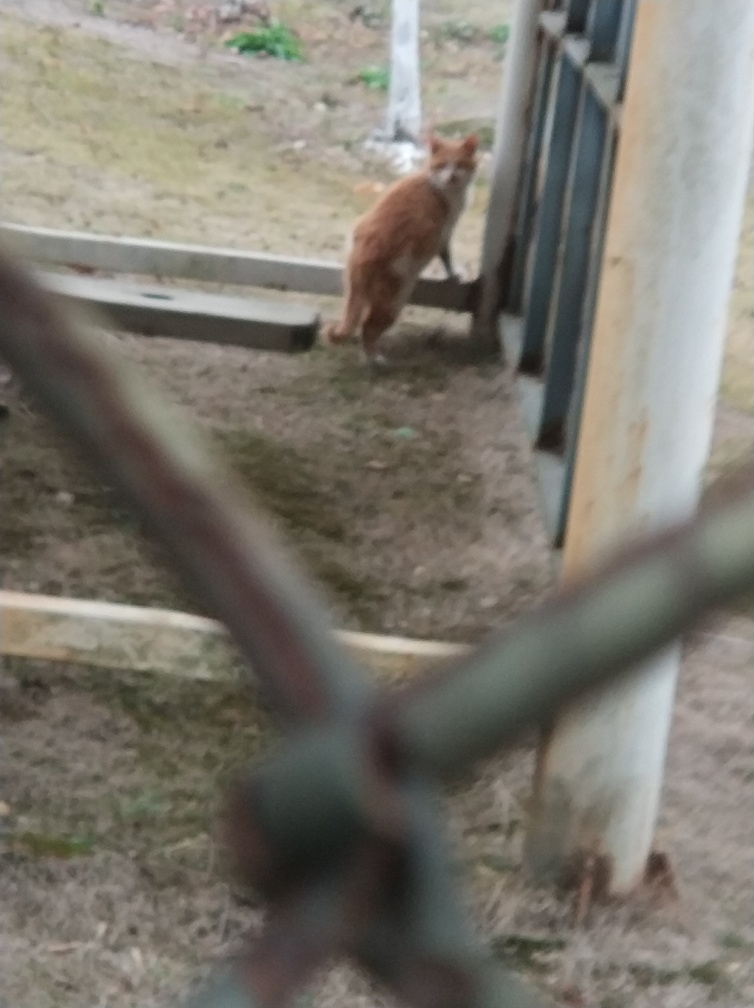This photo seems to be taken from behind a fence, what does this perspective tell you? The perspective suggests a concealed or private viewpoint, as if the photographer is observing without directly interacting with the scene, which adds a sense of distance or separation from the subject. 